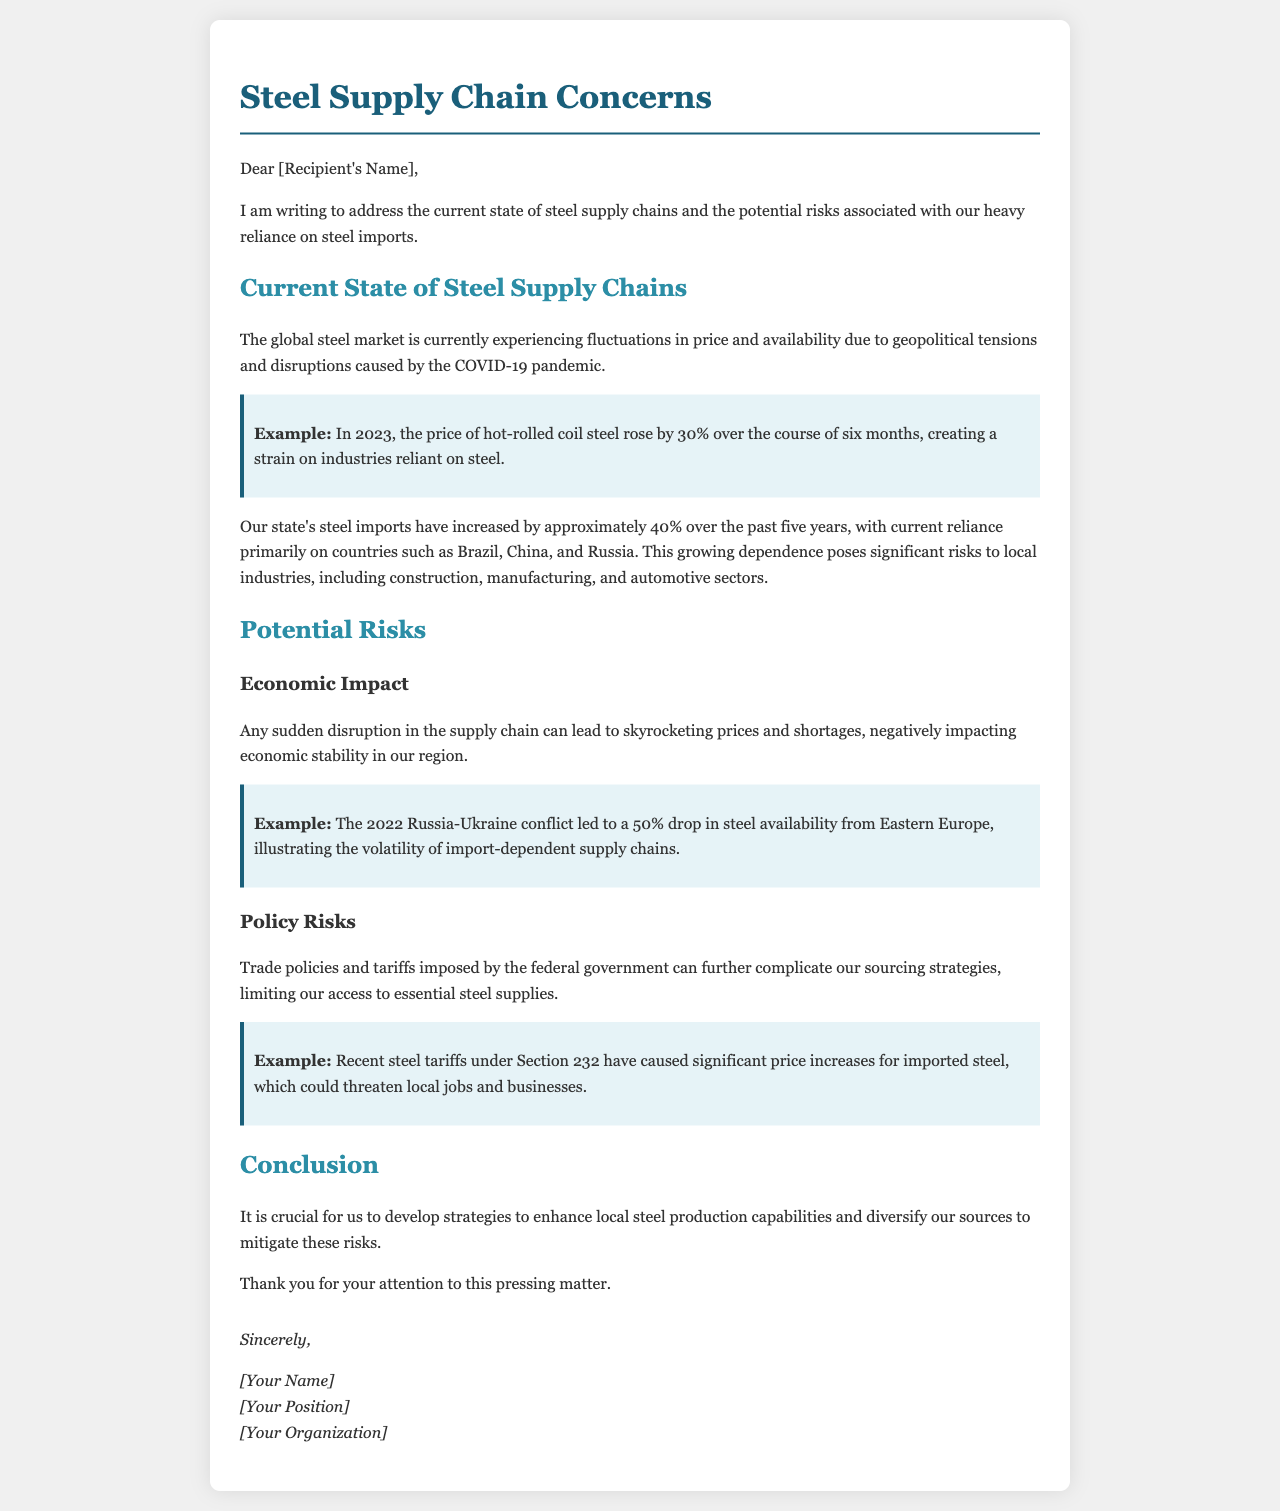What is the main subject of the letter? The main subject of the letter is the current state of steel supply chains and the risks associated with reliance on imports.
Answer: Steel supply chains What percentage did the price of hot-rolled coil steel rise in 2023? The document states that the price of hot-rolled coil steel rose by 30% over six months.
Answer: 30% Which countries are mentioned as primary sources for steel imports? The letter lists Brazil, China, and Russia as primary sources for steel imports.
Answer: Brazil, China, and Russia What was the increase in steel imports for the state over the past five years? The document mentions an increase of approximately 40% in steel imports over the past five years.
Answer: 40% What significant event in 2022 affected steel availability and by what percentage? The 2022 Russia-Ukraine conflict led to a 50% drop in steel availability from Eastern Europe.
Answer: 50% What is a critical strategy suggested to mitigate risks in steel supply chains? The document suggests developing strategies to enhance local steel production capabilities.
Answer: Enhance local steel production capabilities What federal policy might complicate sourcing strategies? The letter mentions trade policies and tariffs imposed by the federal government as complicating factors.
Answer: Trade policies and tariffs What can sudden disruptions in the supply chain lead to? Sudden disruptions in the supply chain can lead to skyrocketing prices and shortages.
Answer: Skyrocketing prices and shortages 